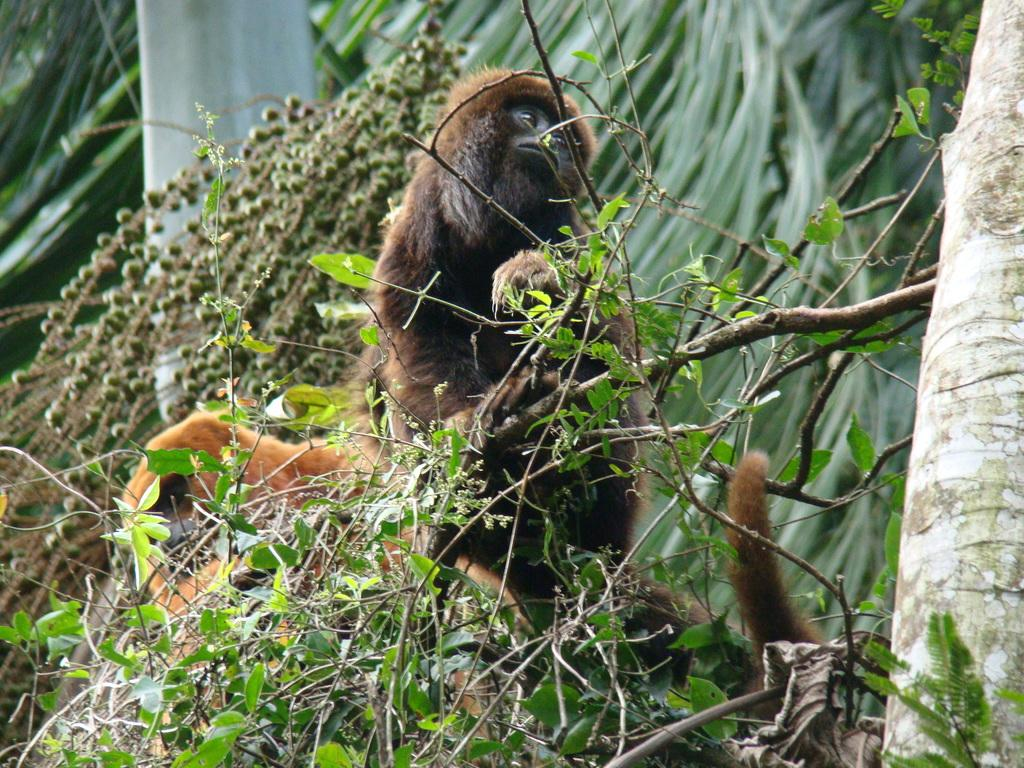What animals are in the center of the image? There are monkeys in the center of the image. Where are the monkeys located? The monkeys are on a tree. What can be seen in the background of the image? There are other trees in the background of the image. What is the person's opinion about the weather in the image? There is no person present in the image, so it is not possible to determine their opinion about the weather. 